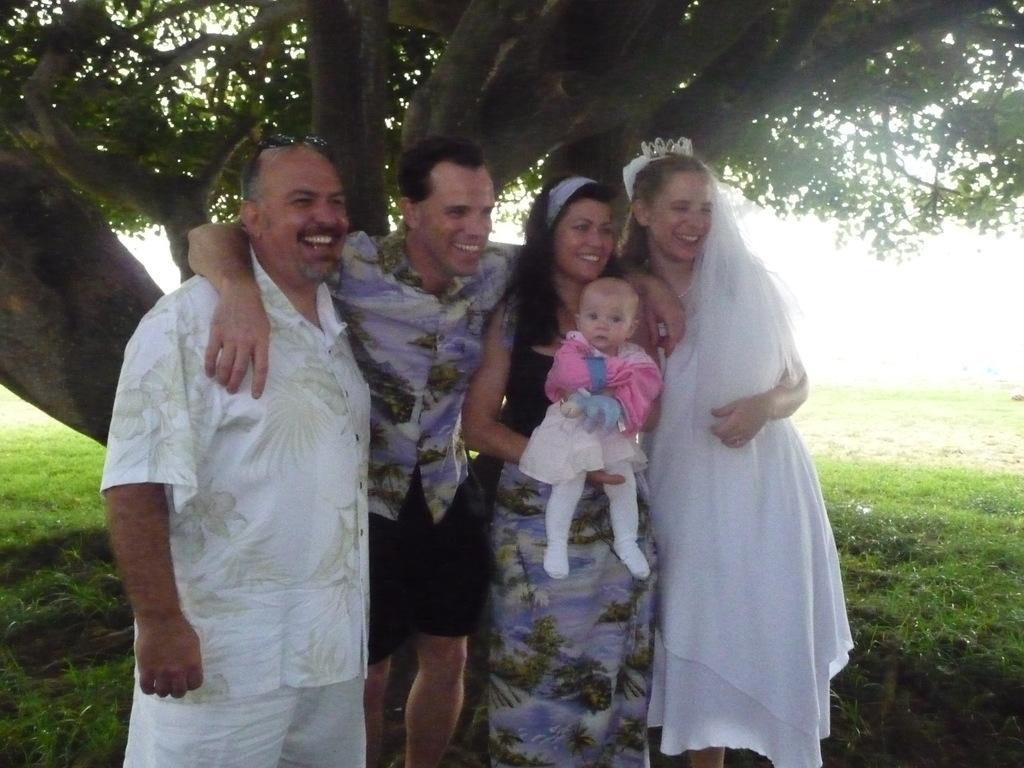How would you summarize this image in a sentence or two? There are two men and two women standing and smiling. This woman is holding a baby in her hands. This is the grass. I can see a tree with branches and leaves. 